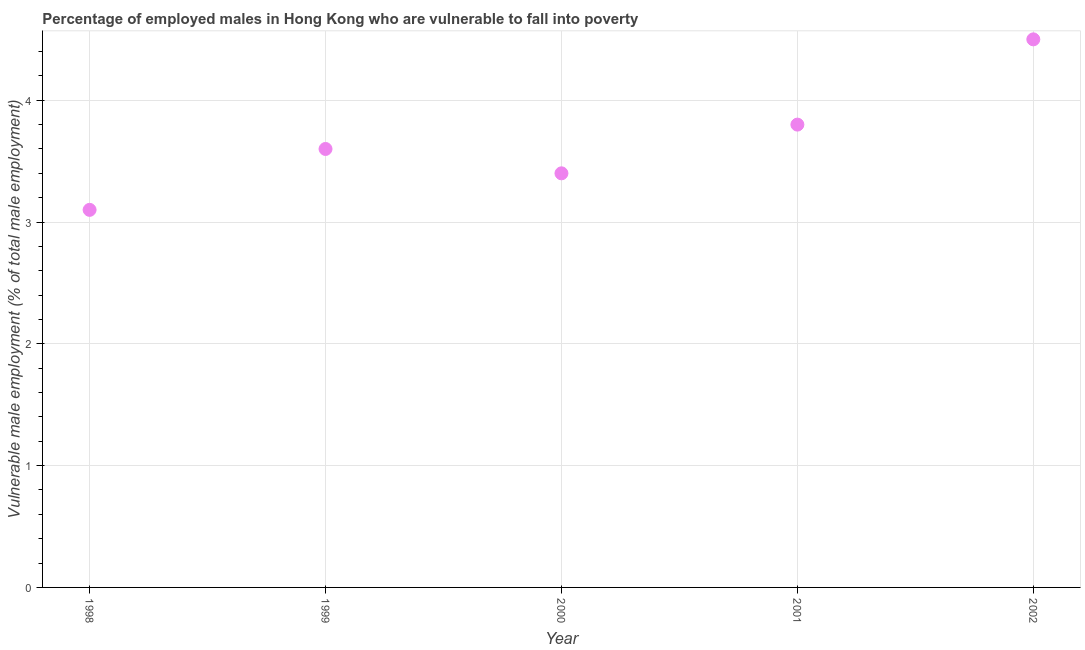What is the percentage of employed males who are vulnerable to fall into poverty in 2001?
Ensure brevity in your answer.  3.8. Across all years, what is the minimum percentage of employed males who are vulnerable to fall into poverty?
Your answer should be compact. 3.1. What is the sum of the percentage of employed males who are vulnerable to fall into poverty?
Make the answer very short. 18.4. What is the difference between the percentage of employed males who are vulnerable to fall into poverty in 1998 and 2000?
Provide a succinct answer. -0.3. What is the average percentage of employed males who are vulnerable to fall into poverty per year?
Make the answer very short. 3.68. What is the median percentage of employed males who are vulnerable to fall into poverty?
Your answer should be very brief. 3.6. What is the ratio of the percentage of employed males who are vulnerable to fall into poverty in 2001 to that in 2002?
Provide a short and direct response. 0.84. Is the difference between the percentage of employed males who are vulnerable to fall into poverty in 1998 and 2000 greater than the difference between any two years?
Provide a succinct answer. No. What is the difference between the highest and the second highest percentage of employed males who are vulnerable to fall into poverty?
Make the answer very short. 0.7. What is the difference between the highest and the lowest percentage of employed males who are vulnerable to fall into poverty?
Give a very brief answer. 1.4. Does the percentage of employed males who are vulnerable to fall into poverty monotonically increase over the years?
Provide a short and direct response. No. How many years are there in the graph?
Your response must be concise. 5. Does the graph contain grids?
Provide a short and direct response. Yes. What is the title of the graph?
Your answer should be very brief. Percentage of employed males in Hong Kong who are vulnerable to fall into poverty. What is the label or title of the X-axis?
Provide a short and direct response. Year. What is the label or title of the Y-axis?
Your response must be concise. Vulnerable male employment (% of total male employment). What is the Vulnerable male employment (% of total male employment) in 1998?
Your answer should be compact. 3.1. What is the Vulnerable male employment (% of total male employment) in 1999?
Make the answer very short. 3.6. What is the Vulnerable male employment (% of total male employment) in 2000?
Make the answer very short. 3.4. What is the Vulnerable male employment (% of total male employment) in 2001?
Offer a very short reply. 3.8. What is the Vulnerable male employment (% of total male employment) in 2002?
Offer a very short reply. 4.5. What is the difference between the Vulnerable male employment (% of total male employment) in 1998 and 1999?
Ensure brevity in your answer.  -0.5. What is the difference between the Vulnerable male employment (% of total male employment) in 1998 and 2000?
Your answer should be compact. -0.3. What is the difference between the Vulnerable male employment (% of total male employment) in 1998 and 2001?
Provide a short and direct response. -0.7. What is the difference between the Vulnerable male employment (% of total male employment) in 1999 and 2000?
Your response must be concise. 0.2. What is the difference between the Vulnerable male employment (% of total male employment) in 2000 and 2001?
Your answer should be very brief. -0.4. What is the difference between the Vulnerable male employment (% of total male employment) in 2000 and 2002?
Your response must be concise. -1.1. What is the ratio of the Vulnerable male employment (% of total male employment) in 1998 to that in 1999?
Give a very brief answer. 0.86. What is the ratio of the Vulnerable male employment (% of total male employment) in 1998 to that in 2000?
Ensure brevity in your answer.  0.91. What is the ratio of the Vulnerable male employment (% of total male employment) in 1998 to that in 2001?
Offer a terse response. 0.82. What is the ratio of the Vulnerable male employment (% of total male employment) in 1998 to that in 2002?
Your answer should be very brief. 0.69. What is the ratio of the Vulnerable male employment (% of total male employment) in 1999 to that in 2000?
Provide a succinct answer. 1.06. What is the ratio of the Vulnerable male employment (% of total male employment) in 1999 to that in 2001?
Offer a terse response. 0.95. What is the ratio of the Vulnerable male employment (% of total male employment) in 1999 to that in 2002?
Your answer should be very brief. 0.8. What is the ratio of the Vulnerable male employment (% of total male employment) in 2000 to that in 2001?
Ensure brevity in your answer.  0.9. What is the ratio of the Vulnerable male employment (% of total male employment) in 2000 to that in 2002?
Your answer should be very brief. 0.76. What is the ratio of the Vulnerable male employment (% of total male employment) in 2001 to that in 2002?
Your answer should be compact. 0.84. 